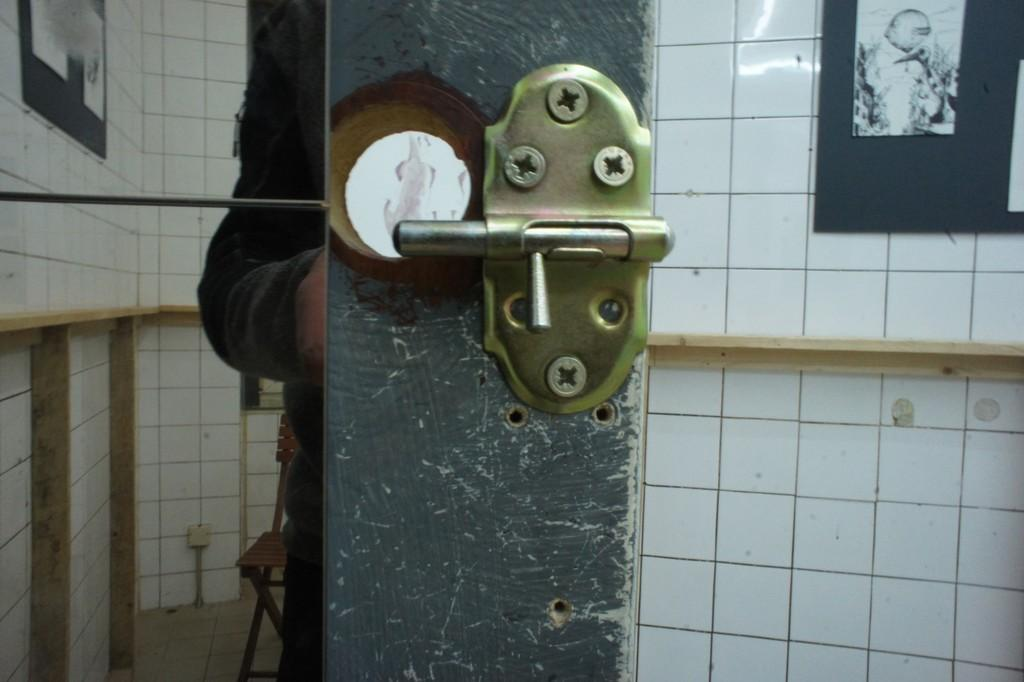What is the person in the image holding? The person is holding a skateboard. What can be seen in the background of the image? There is a ramp visible in the background of the image. What type of crime is being committed in the image? There is no crime being committed in the image; it shows a person holding a skateboard and a ramp in the background. 